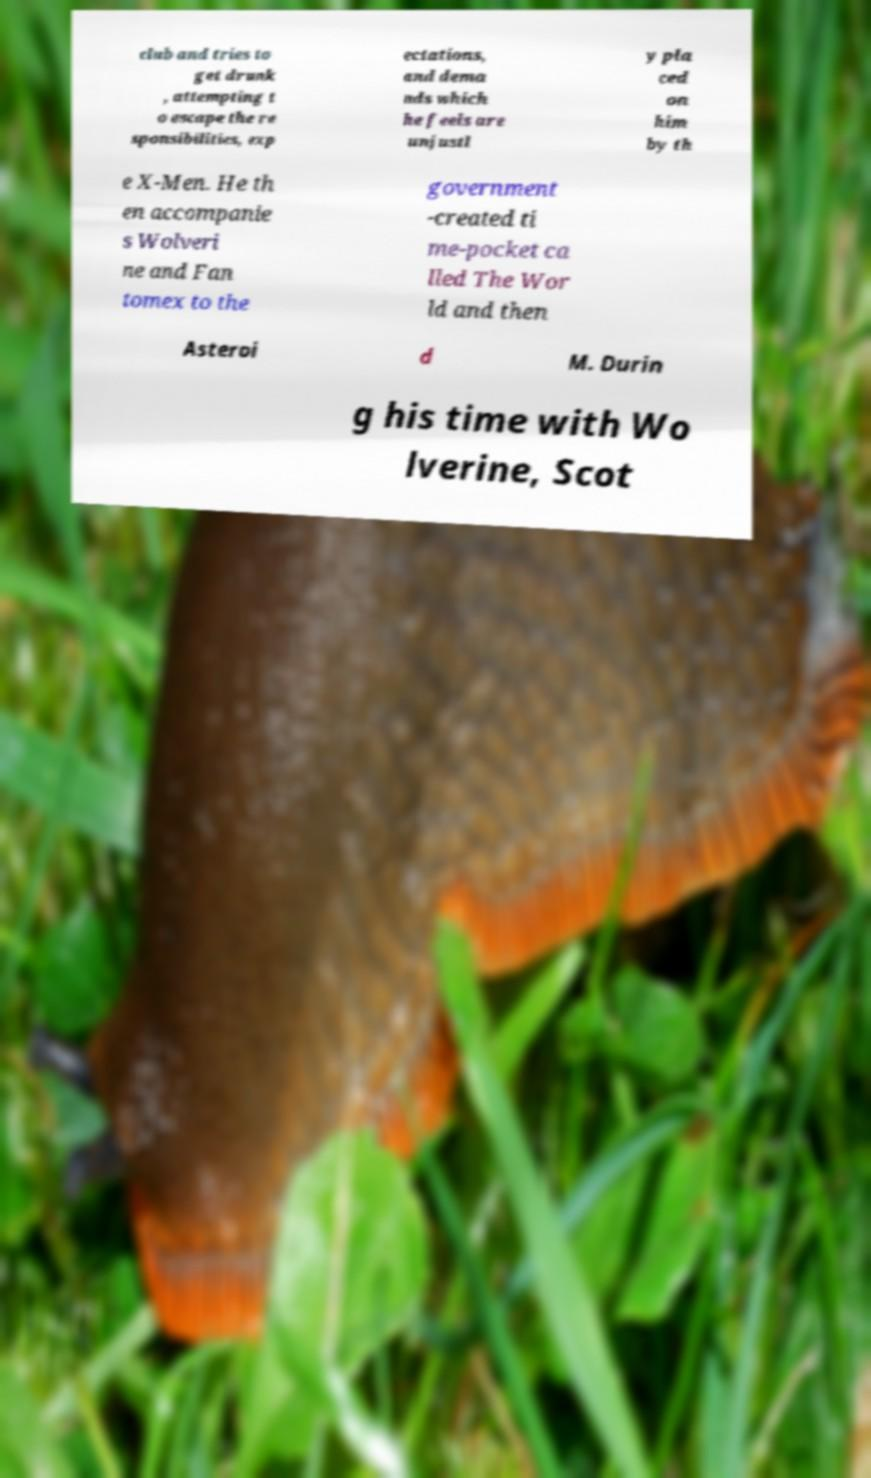Please identify and transcribe the text found in this image. club and tries to get drunk , attempting t o escape the re sponsibilities, exp ectations, and dema nds which he feels are unjustl y pla ced on him by th e X-Men. He th en accompanie s Wolveri ne and Fan tomex to the government -created ti me-pocket ca lled The Wor ld and then Asteroi d M. Durin g his time with Wo lverine, Scot 